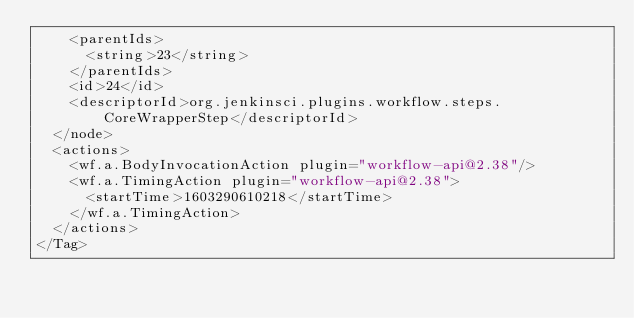<code> <loc_0><loc_0><loc_500><loc_500><_XML_>    <parentIds>
      <string>23</string>
    </parentIds>
    <id>24</id>
    <descriptorId>org.jenkinsci.plugins.workflow.steps.CoreWrapperStep</descriptorId>
  </node>
  <actions>
    <wf.a.BodyInvocationAction plugin="workflow-api@2.38"/>
    <wf.a.TimingAction plugin="workflow-api@2.38">
      <startTime>1603290610218</startTime>
    </wf.a.TimingAction>
  </actions>
</Tag></code> 